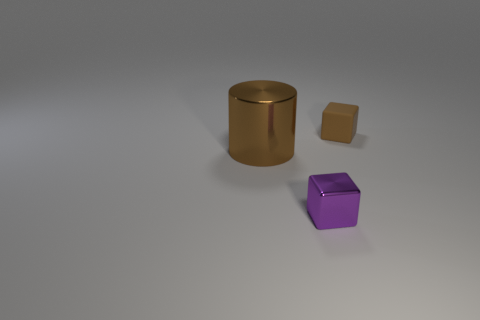What is the shape of the purple object that is the same size as the brown matte object?
Ensure brevity in your answer.  Cube. Are there any tiny matte things of the same shape as the big metal thing?
Provide a succinct answer. No. Are there any purple shiny objects in front of the small metallic thing in front of the brown thing to the left of the small purple object?
Provide a short and direct response. No. Are there more tiny brown objects in front of the large metal cylinder than brown matte things that are in front of the brown rubber thing?
Keep it short and to the point. No. There is a purple block that is the same size as the brown matte block; what material is it?
Provide a succinct answer. Metal. What number of small objects are either cubes or purple metallic objects?
Make the answer very short. 2. Is the matte object the same shape as the large thing?
Offer a very short reply. No. What number of objects are both on the right side of the brown cylinder and behind the tiny purple cube?
Give a very brief answer. 1. Is there anything else of the same color as the big cylinder?
Provide a short and direct response. Yes. There is a object that is the same material as the purple block; what shape is it?
Offer a terse response. Cylinder. 